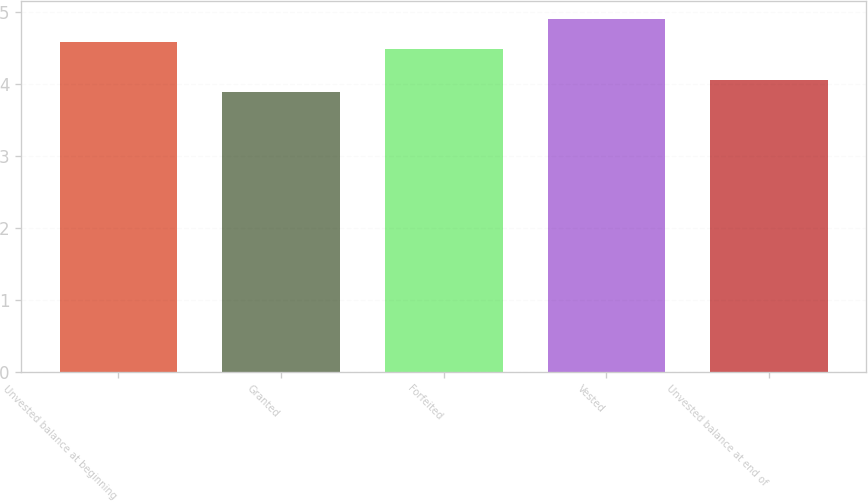<chart> <loc_0><loc_0><loc_500><loc_500><bar_chart><fcel>Unvested balance at beginning<fcel>Granted<fcel>Forfeited<fcel>Vested<fcel>Unvested balance at end of<nl><fcel>4.58<fcel>3.89<fcel>4.48<fcel>4.9<fcel>4.05<nl></chart> 